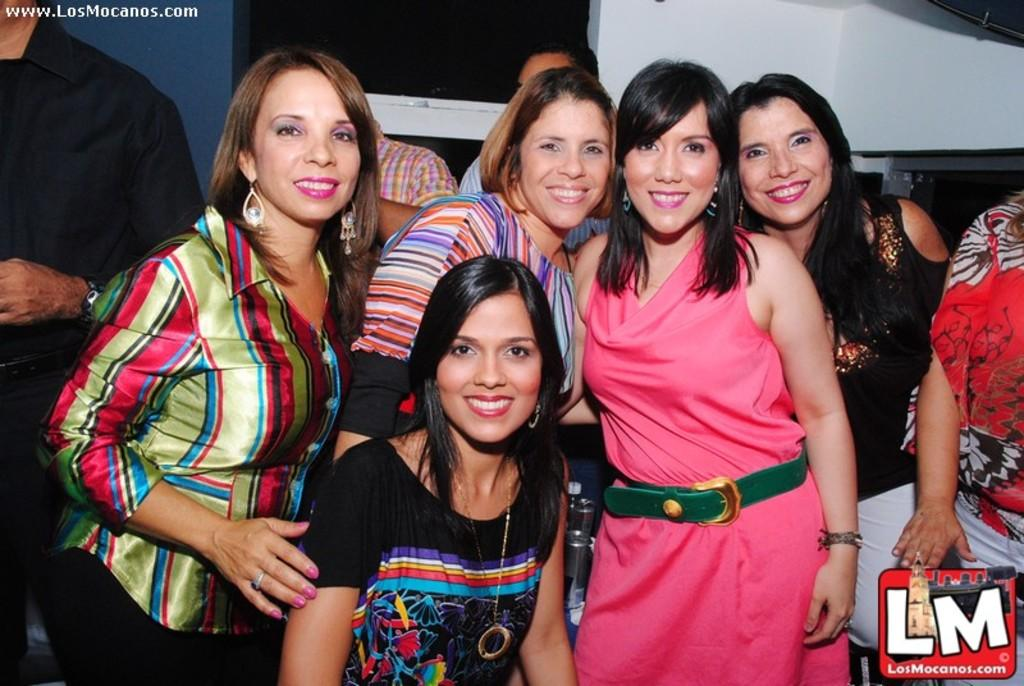How many girls are present in the image? There are many girls in the image. What is the woman in the front of the image wearing? The woman is wearing a black dress in the front of the image. What can be seen in the background of the image? There is a wall and a window in the background of the image. Where is the man positioned in the image? The man is standing to the left of the image. What color is the orange that the girls are holding in the image? There is no orange present in the image; the girls are not holding any oranges. What is the neck size of the woman in the black dress? The neck size of the woman cannot be determined from the image, as it does not provide such specific details. 